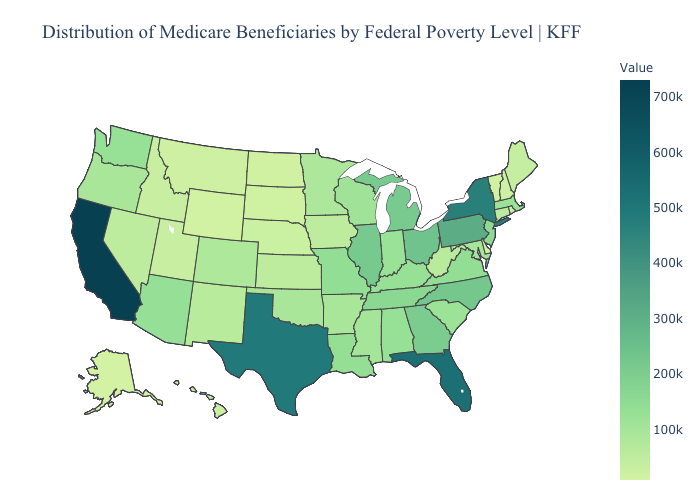Among the states that border Arkansas , which have the highest value?
Write a very short answer. Texas. Which states have the highest value in the USA?
Give a very brief answer. California. Which states hav the highest value in the MidWest?
Quick response, please. Ohio. Does Nebraska have the highest value in the MidWest?
Keep it brief. No. 